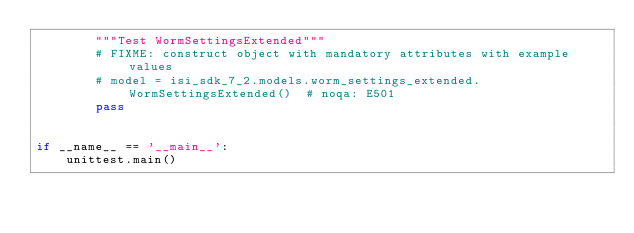<code> <loc_0><loc_0><loc_500><loc_500><_Python_>        """Test WormSettingsExtended"""
        # FIXME: construct object with mandatory attributes with example values
        # model = isi_sdk_7_2.models.worm_settings_extended.WormSettingsExtended()  # noqa: E501
        pass


if __name__ == '__main__':
    unittest.main()
</code> 